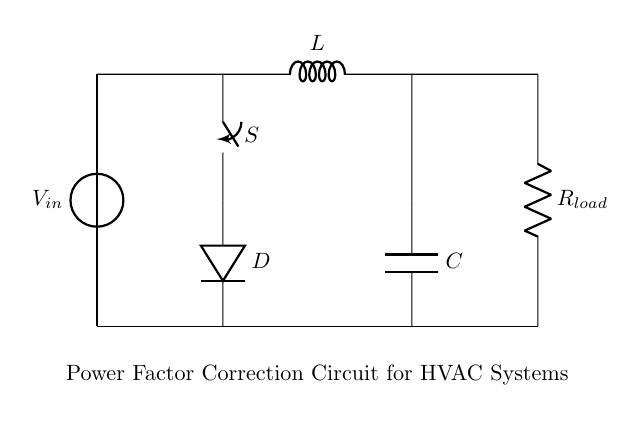What is the total number of components in this circuit? The circuit consists of a voltage source, an inductor, a resistor, a capacitor, a switch, and a diode, totaling six distinct components.
Answer: six What is the role of the capacitor in this circuit? The capacitor is connected in parallel with the load and is used for power factor correction by compensating for the inductive reactance of the load.
Answer: power factor correction What is the purpose of the switch in this circuit? The switch allows the operator to connect or disconnect the capacitor from the circuit, enabling or disabling the power factor correction functionality as needed.
Answer: connect or disconnect How does the diode affect the operation of the circuit? The diode prevents current from flowing back into the circuit when the capacitor discharges, thereby ensuring unidirectional current flow and protecting other components.
Answer: prevents reverse current What type of circuit is depicted in the diagram? The circuit is a power factor correction circuit specifically designed for industrial HVAC systems, aimed at reducing energy costs associated with inductive loads.
Answer: power factor correction circuit 